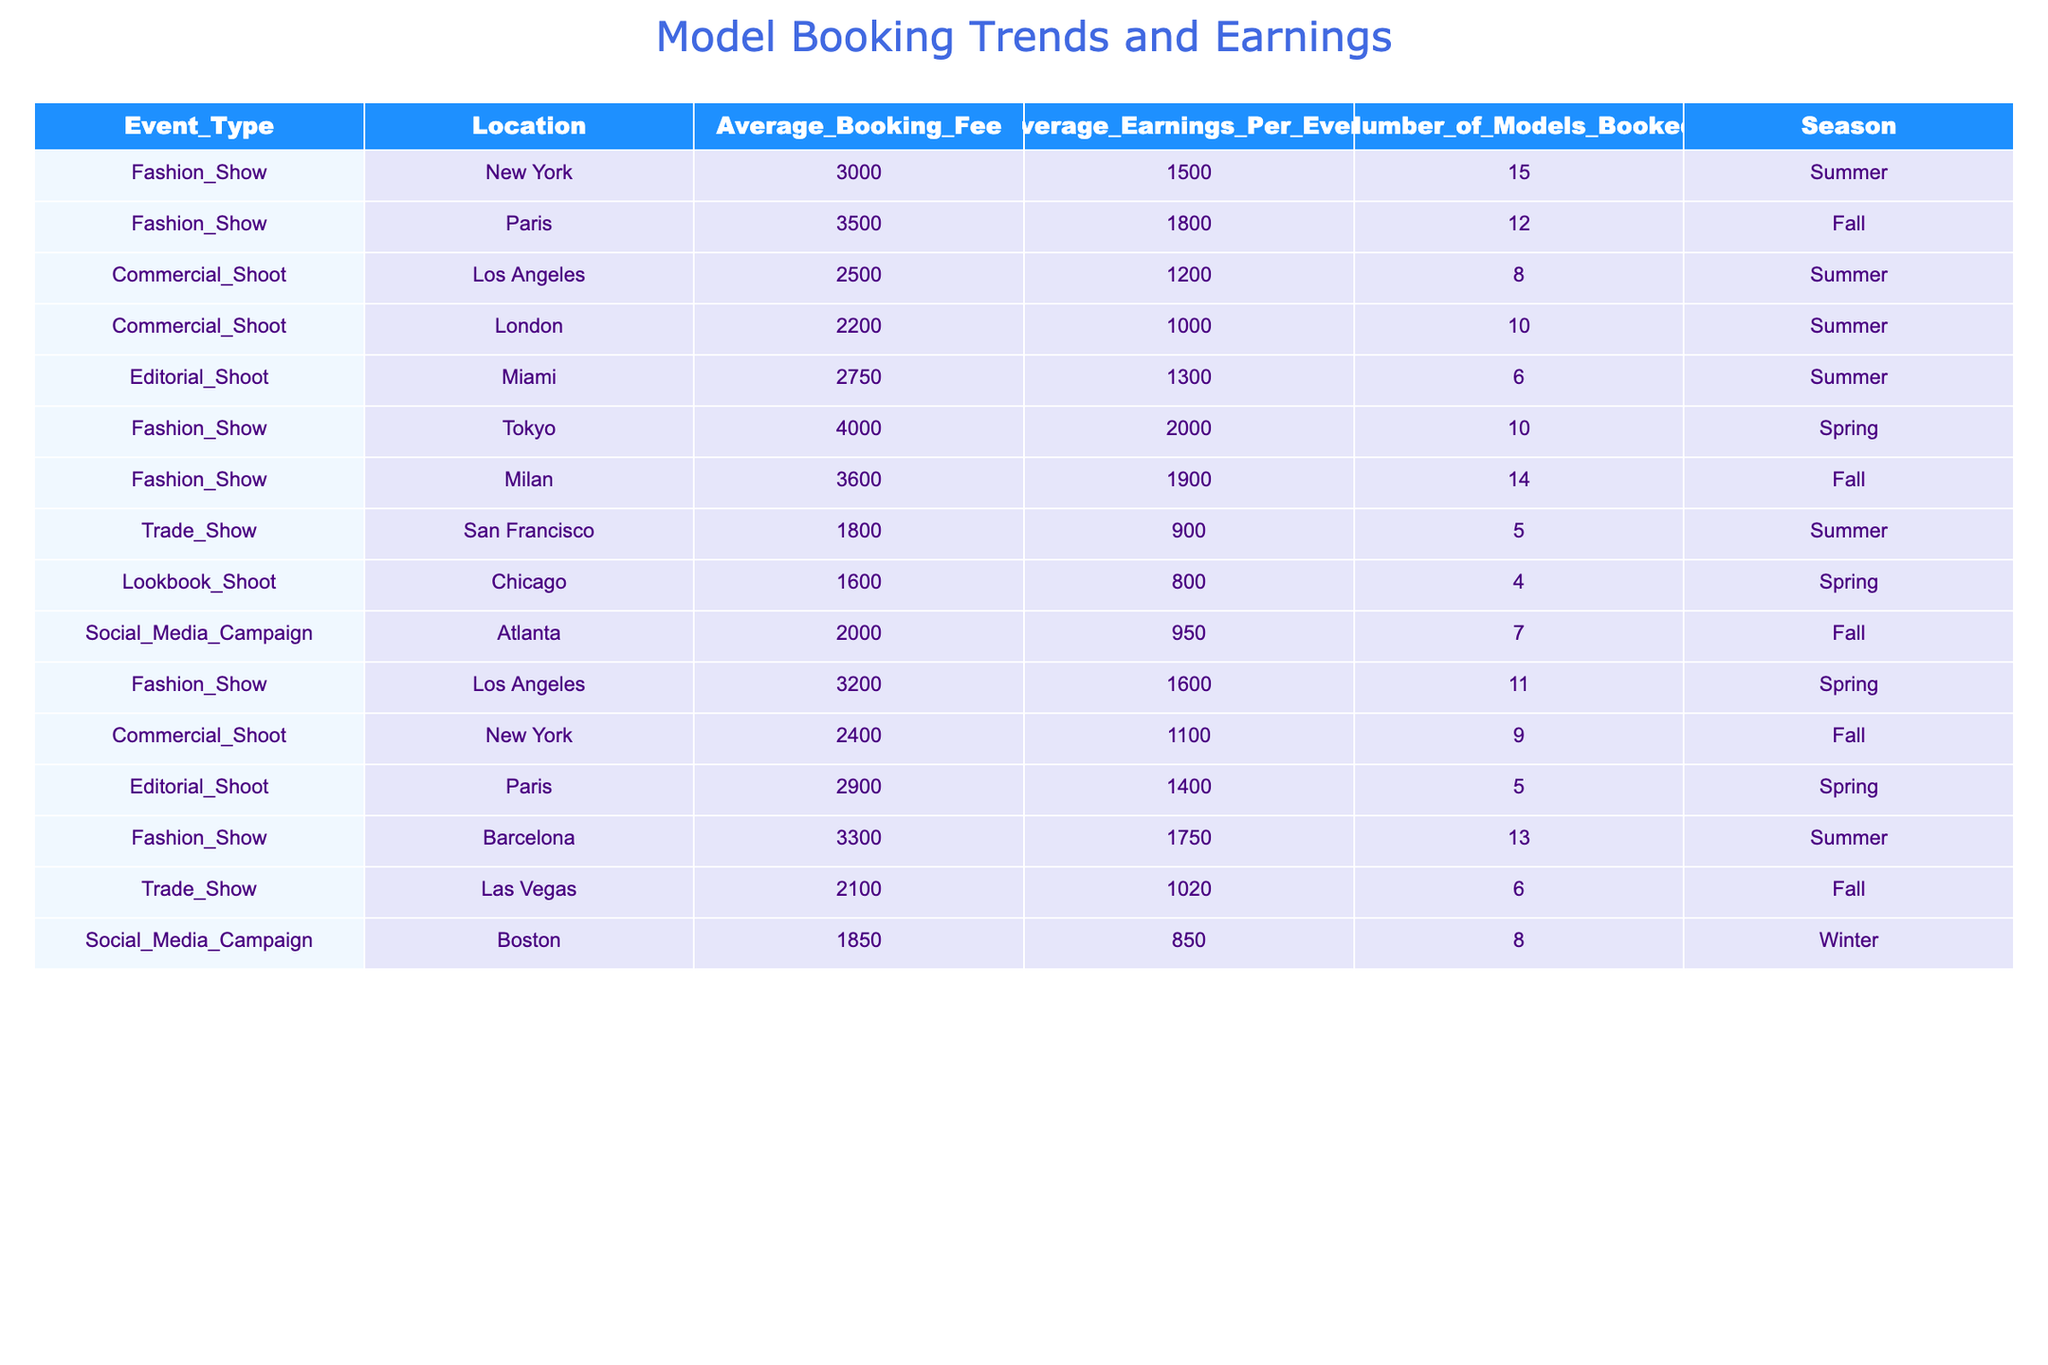What is the average booking fee for a Fashion Show in New York? In the table, the average booking fee for the Fashion Show listed under New York is specifically found as 3000.
Answer: 3000 How many models were booked for the Editorial Shoot in Paris? Referring to the table, the number of models booked for the Editorial Shoot in Paris is noted as 5.
Answer: 5 What is the average earning per event for the Commercial Shoot in Los Angeles and New York combined? For the Commercial Shoot in Los Angeles, the average earnings per event is 1200, and for New York, it is 1100. Adding these together gives 1200 + 1100 = 2300, and dividing by 2 for the average yields 2300 / 2 = 1150.
Answer: 1150 Is the average booking fee for a Trade Show higher in Las Vegas than in San Francisco? The average booking fee for the Trade Show in Las Vegas is 2100, while in San Francisco it is 1800. Since 2100 is greater than 1800, the statement is true.
Answer: Yes Which season had the highest average earnings for Fashion Shows? The average earnings for Fashion Shows by season from the table are Spring with 2000 (Tokyo), Summer with 1750 (Barcelona), and Fall with 1900 (Milan and Paris). The highest value is 2000 for the Spring season.
Answer: Spring What is the total number of models booked for all events in Summer? Summing the number of models booked for the Summer events listed: Fashion Show (15 + 12) + Commercial Shoot (8) + Editorial Shoot (6) + Trade Show (5) + Barcelona (13) + Social Media Campaign (7) gives us a total of 15 + 12 + 8 + 6 + 13 + 7 = 61.
Answer: 61 Is there an Editorial Shoot event in Tokyo? By checking the table, it can be confirmed that there is no Editorial Shoot event listed in Tokyo, therefore the statement is false.
Answer: No What is the highest average booking fee for a Fashion Show and which city does it correspond to? The average booking fees for Fashion Shows are: New York (3000), Paris (3500), Tokyo (4000), Milan (3600), and Barcelona (3300). The highest is 4000 for Tokyo.
Answer: Tokyo, 4000 How does the average earnings per event for Social Media Campaigns compare between Boston and Atlanta? In the table, the average earnings for the Social Media Campaign in Boston is 850 and in Atlanta is 950. Atlanta's amount is greater than Boston's, which determines that the average earnings for Atlanta is higher.
Answer: Atlanta has higher earnings 